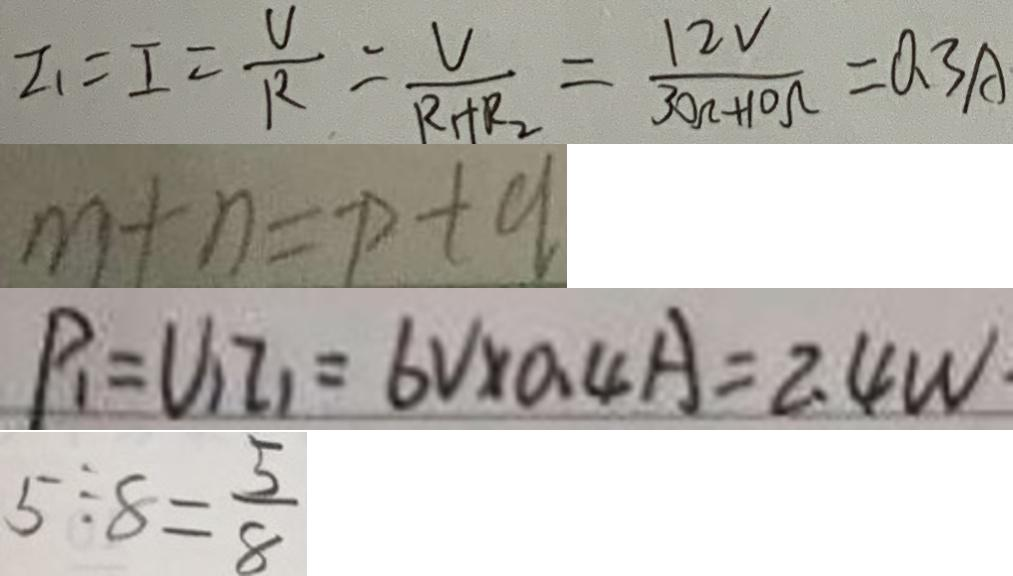Convert formula to latex. <formula><loc_0><loc_0><loc_500><loc_500>I _ { 1 } = I = \frac { U } { R } = \frac { V } { R + R _ { 2 } } = \frac { 1 2 V } { 3 0 k + 1 0 \Omega } = 0 . 3 A 
 m + n = p + q 
 P _ { 1 } = U _ { 1 } I _ { 1 } = 6 V \times 0 . 4 A = 2 . 4 W 
 5 \div 8 = \frac { 5 } { 8 }</formula> 